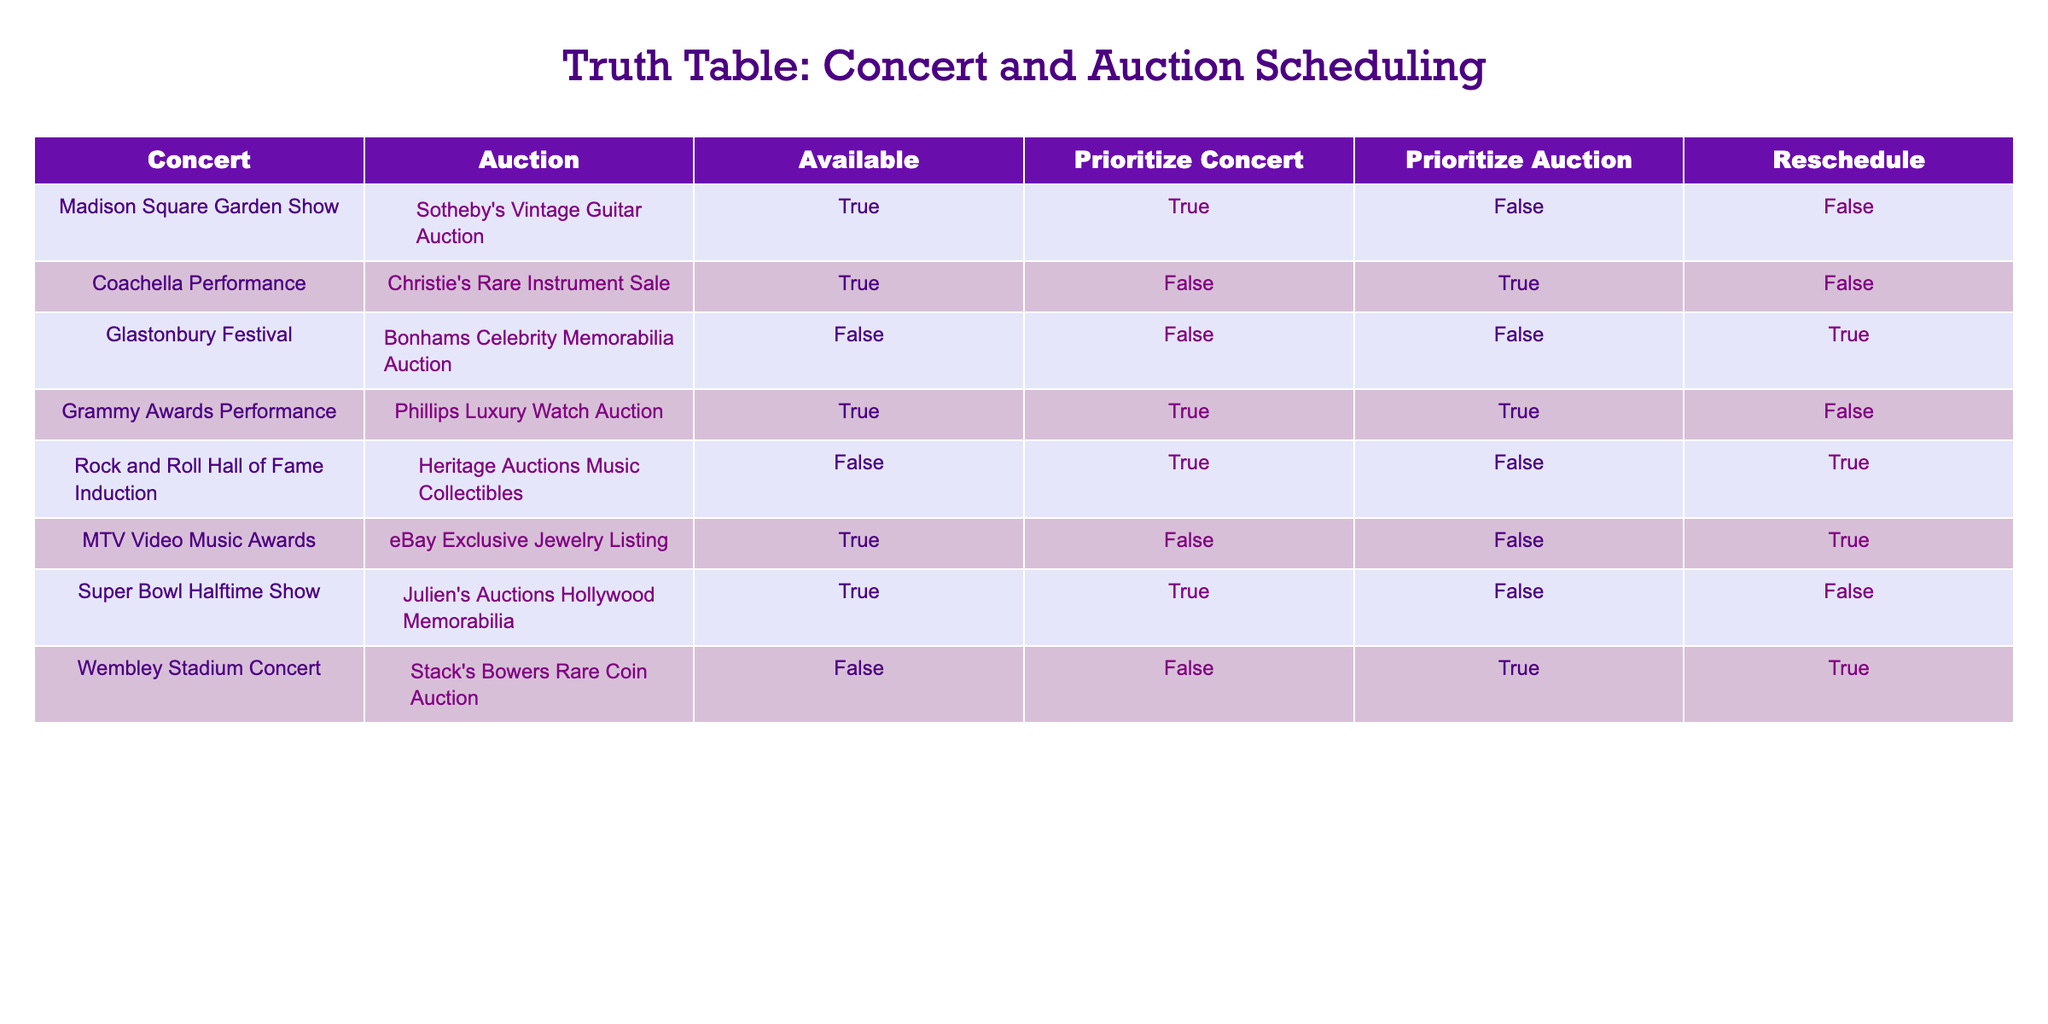What is the first concert listed in the table? The first row in the table provides the information about the Madison Square Garden Show, so it is simply obtained by looking at the first entry.
Answer: Madison Square Garden Show How many events are available for both concert and auction? By looking at the "Available" column in the table, I can see that only three events (Madison Square Garden Show, Coachella Performance, and Grammy Awards Performance) have "TRUE" for availability, so I count those entries.
Answer: 3 Is it true that there are more events prioritizing concerts than those prioritizing auctions? To determine this, I count how many rows have "TRUE" under the "Prioritize Concert" column (5 events) and under the "Prioritize Auction" column (2 events). Since 5 is greater than 2, the statement is true.
Answer: Yes Which auction is associated with the Grammy Awards Performance? By locating the row for the Grammy Awards Performance, the corresponding auction is found in the same row under the "Auction" column, which shows Phillips Luxury Watch Auction.
Answer: Phillips Luxury Watch Auction If I prioritize auctions, how many events need to be rescheduled? First, I look in the "Reschedule" column for events where "Prioritize Auction" is "TRUE." There are two occurrences: Glastonbury Festival and Wembley Stadium Concert, which both need to be rescheduled.
Answer: 2 What is the auction for the event that is not available? There are two events that are marked as not available in the "Available" column (Glastonbury Festival and Rock and Roll Hall of Fame Induction). The auctions are Bonhams Celebrity Memorabilia Auction and Heritage Auctions Music Collectibles.
Answer: Bonhams Celebrity Memorabilia Auction; Heritage Auctions Music Collectibles Count how many events do not require rescheduling if prioritizing concerts. Looking at the table, I find instances where "Prioritize Concert" is "TRUE" and "Reschedule" is "FALSE." Only Madison Square Garden Show and Grammy Awards Performance fit this criteria. So, the total is 2.
Answer: 2 Is there any event scheduled at the same time that allows for prioritizing both concert and auction? By examining the table, only the Grammy Awards Performance shows both "Prioritize Concert" and "Prioritize Auction" as "TRUE." All other events do not allow this simultaneous prioritization.
Answer: Yes What is the total number of performance events scheduled in the table? Counting every entry in the "Concert" column gives a total of 8 performance events listed in the table. Each row represents a distinct concert event.
Answer: 8 